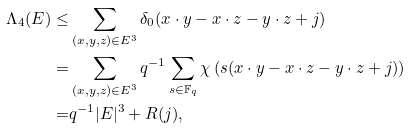<formula> <loc_0><loc_0><loc_500><loc_500>\Lambda _ { 4 } ( E ) \leq & \sum _ { ( x , y , z ) \in E ^ { 3 } } \delta _ { 0 } ( x \cdot y - x \cdot z - y \cdot z + j ) \\ = & \sum _ { ( x , y , z ) \in E ^ { 3 } } q ^ { - 1 } \sum _ { s \in { \mathbb { F } } _ { q } } \chi \left ( s ( x \cdot y - x \cdot z - y \cdot z + j ) \right ) \\ = & q ^ { - 1 } | E | ^ { 3 } + R ( j ) ,</formula> 